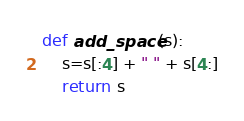<code> <loc_0><loc_0><loc_500><loc_500><_Python_>def add_space(s):
    s=s[:4] + " " + s[4:]
    return s
</code> 